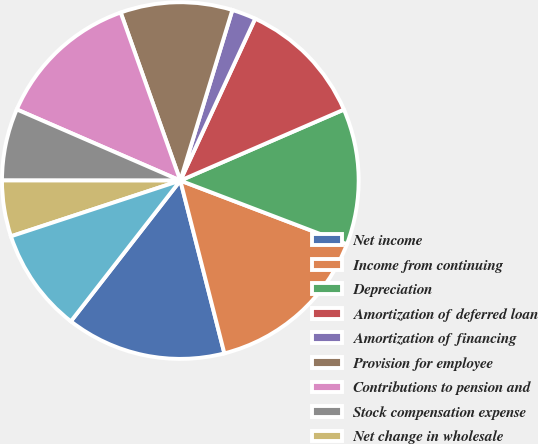Convert chart. <chart><loc_0><loc_0><loc_500><loc_500><pie_chart><fcel>Net income<fcel>Income from continuing<fcel>Depreciation<fcel>Amortization of deferred loan<fcel>Amortization of financing<fcel>Provision for employee<fcel>Contributions to pension and<fcel>Stock compensation expense<fcel>Net change in wholesale<fcel>Provision for credit losses<nl><fcel>14.49%<fcel>15.22%<fcel>12.32%<fcel>11.59%<fcel>2.18%<fcel>10.14%<fcel>13.04%<fcel>6.52%<fcel>5.07%<fcel>9.42%<nl></chart> 